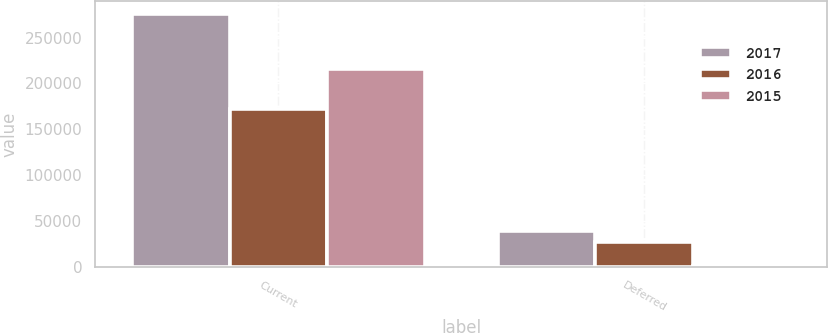Convert chart. <chart><loc_0><loc_0><loc_500><loc_500><stacked_bar_chart><ecel><fcel>Current<fcel>Deferred<nl><fcel>2017<fcel>275475<fcel>39563<nl><fcel>2016<fcel>172380<fcel>27463<nl><fcel>2015<fcel>215703<fcel>1559<nl></chart> 